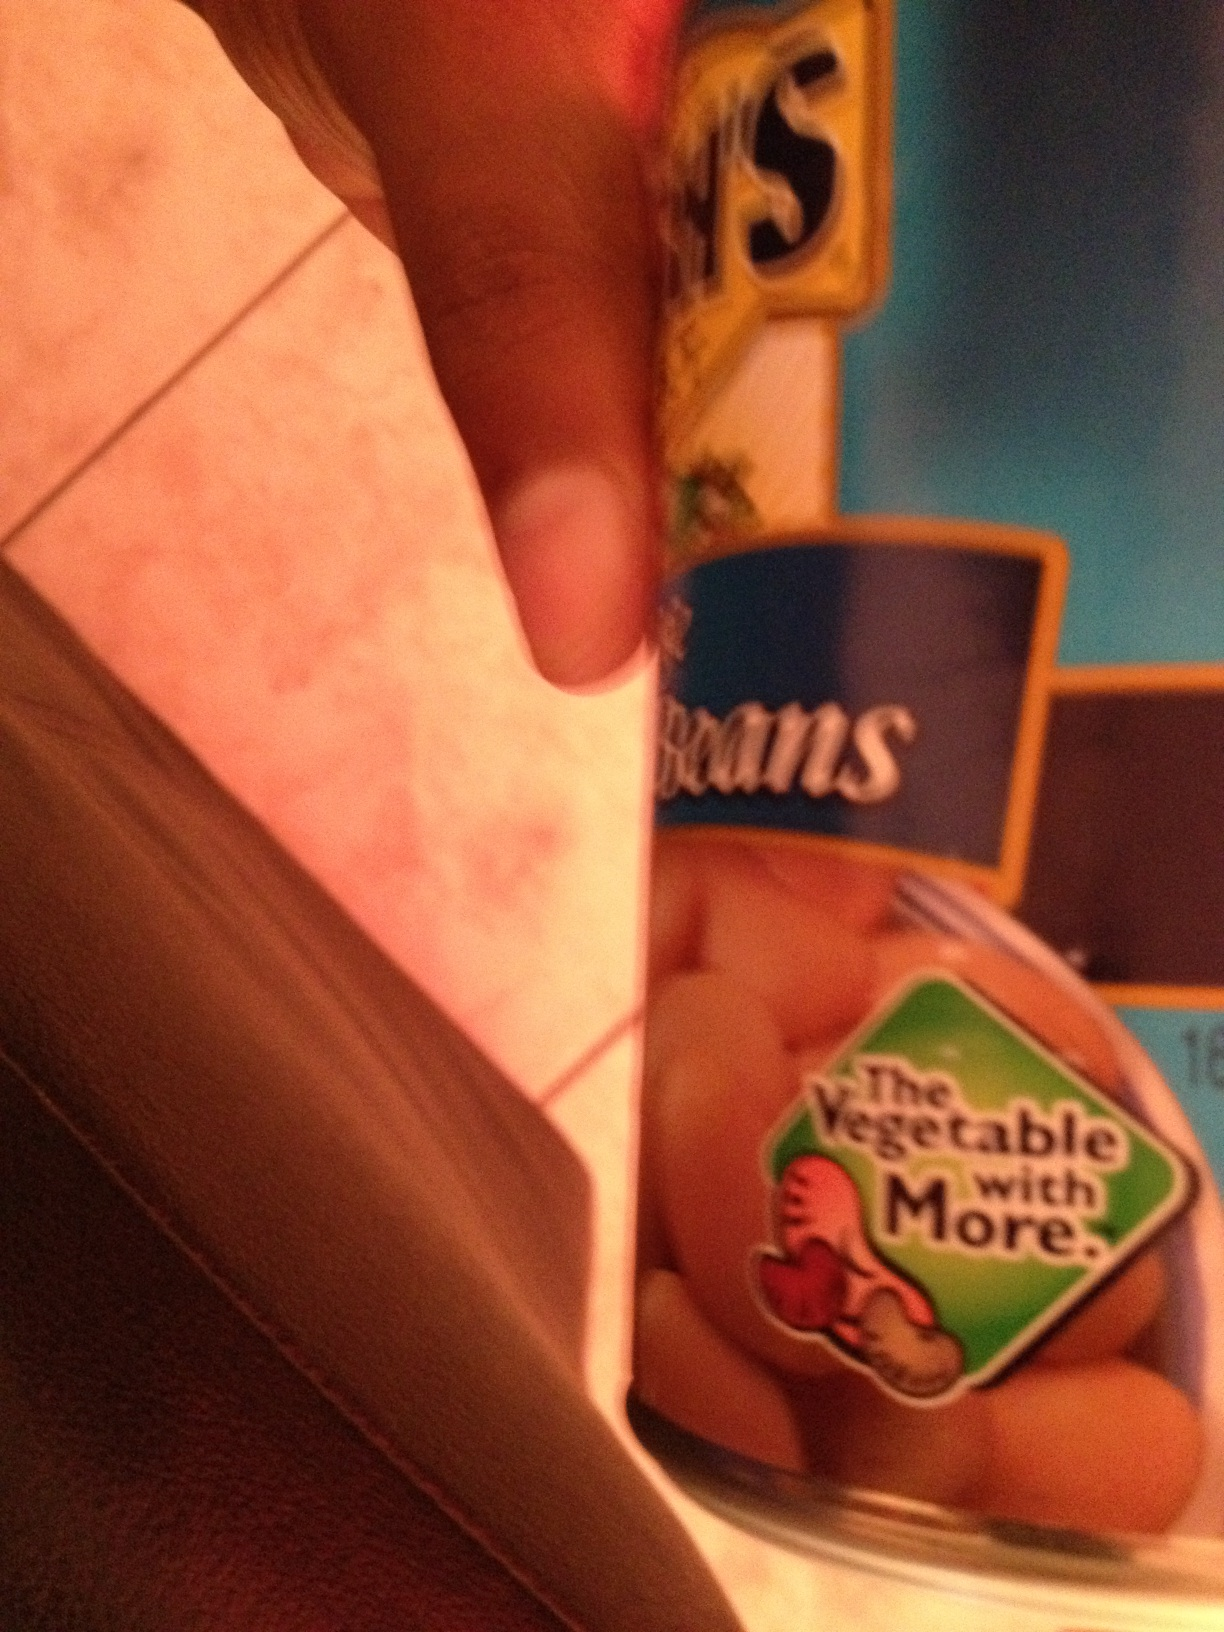Can you tell me more about how pinto beans can be used in meals? Absolutely! Pinto beans are versatile legumes often used in a variety of dishes. You can mash them for refried beans, include them in stews and soups, or mix into salads for extra protein. They also make a hearty base for vegetarian tacos or can be blended into a bean dip for snacks. 